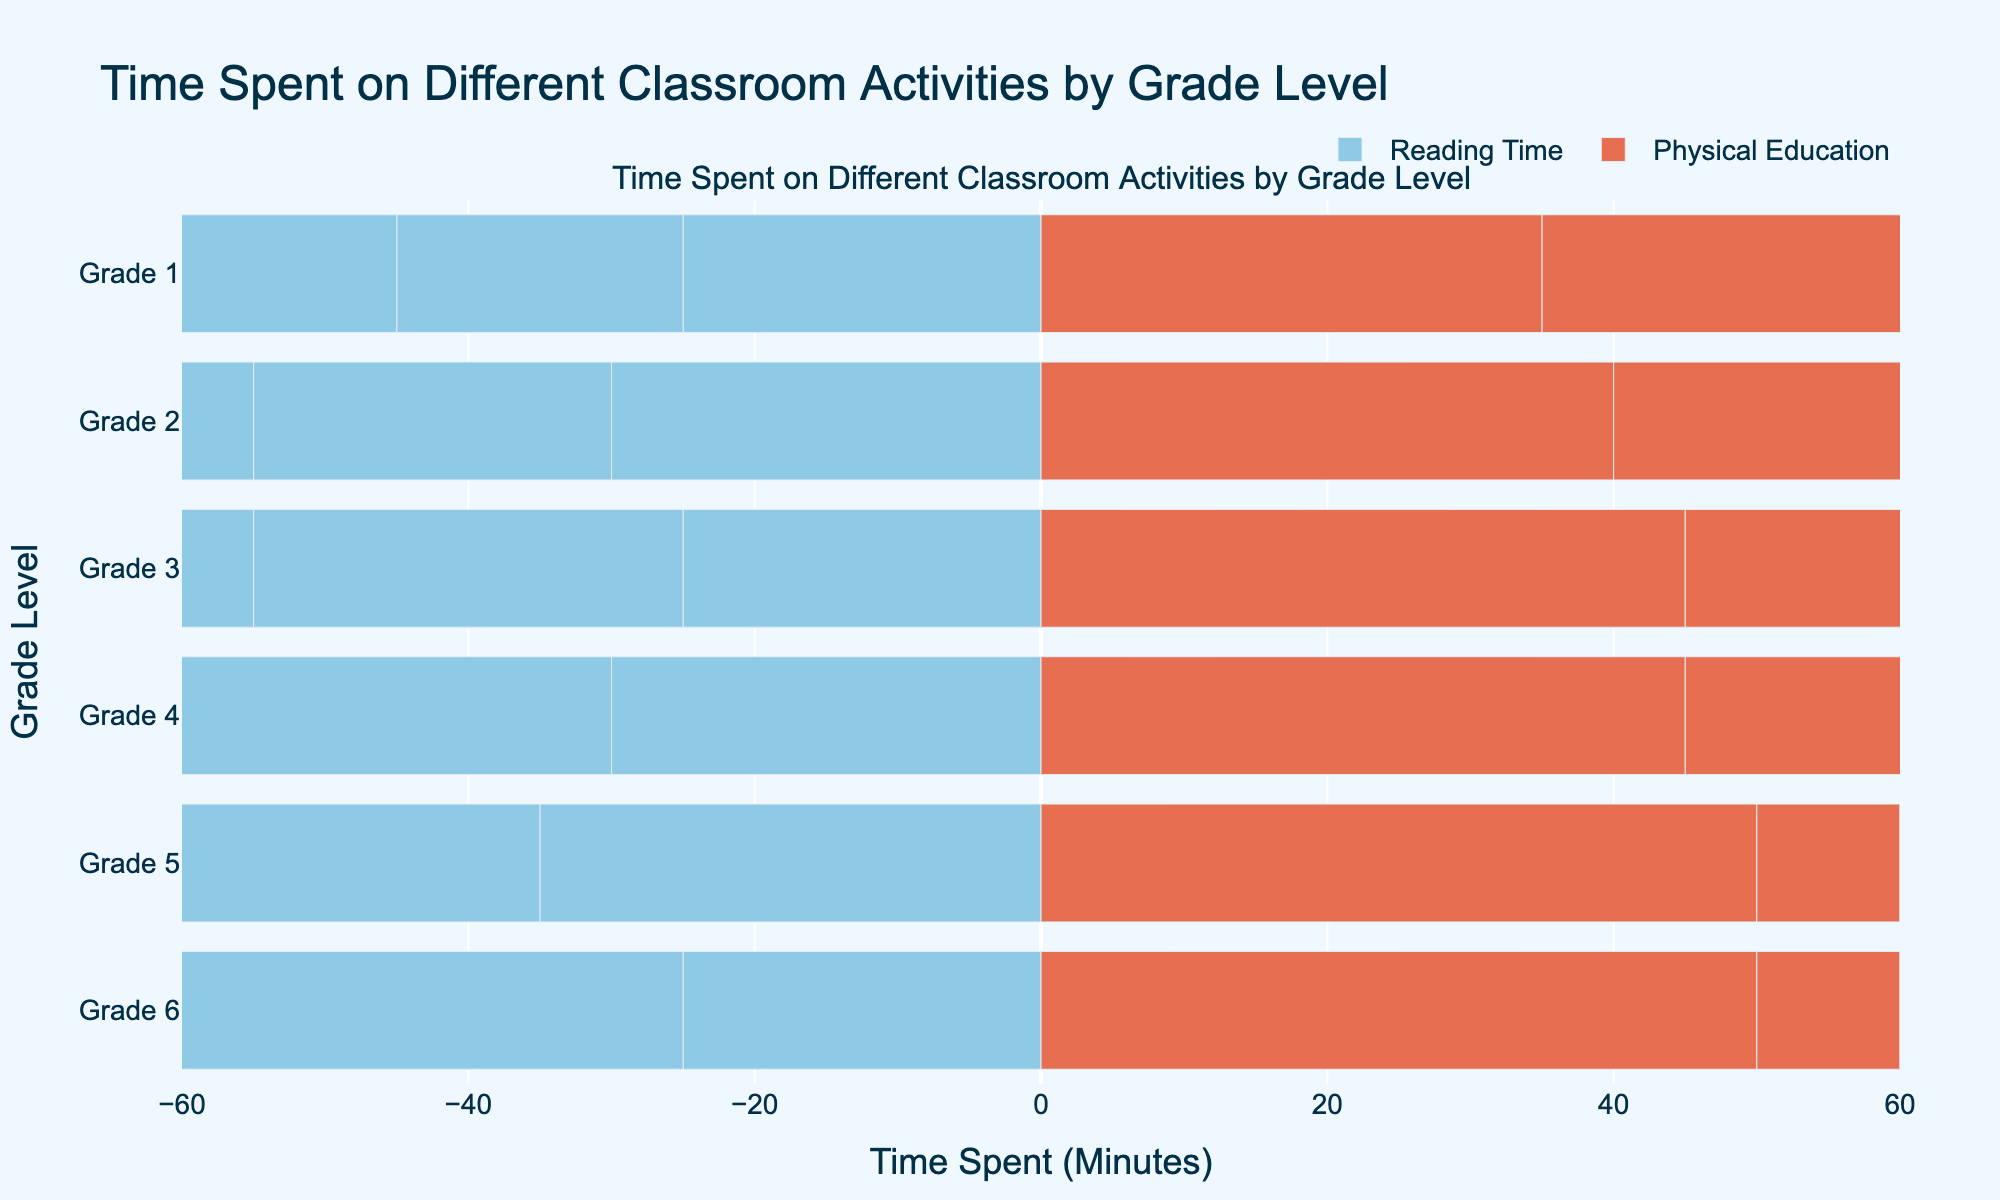What's the total time spent on Reading Time and Math Lessons for Grade 3? For Grade 3: Reading Time is 40 minutes and Math Lessons is 50 minutes. Adding them: 40 + 50 = 90 minutes
Answer: 90 minutes Which grade has the highest total time spent on Physical Education? Check the time values for Physical Education across all grades: Grade 1=35, Grade 2=40, Grade 3=45, Grade 4=45, Grade 5=50, Grade 6=50. The highest value is for Grades 5 and 6.
Answer: Grades 5 and 6 What's the average time spent on Art and Craft across all grades? Time spent on Art and Craft: Grade 1=25, Grade 2=30, Grade 3=25, Grade 4=30, Grade 5=35, Grade 6=25. Calculate the sum: 25 + 30 + 25 + 30 + 35 + 25 = 170. Number of grades is 6. Average: 170 / 6 ≈ 28.33
Answer: ≈ 28.33 minutes Which grade has the smallest time allotted for Snack Break? Check Snack Break times: Grade 1=15, Grade 2=15, Grade 3=10, Grade 4=10, Grade 5=10, Grade 6=10. The smallest value is for Grades 3, 4, 5, and 6.
Answer: Grades 3, 4, 5, and 6 Compare the time spent on Science Experiments between Grade 2 and Grade 4. Which one is higher and by how much? Science Experiments for Grade 2 is 25 minutes and Grade 4 is 35 minutes. Difference: 35 - 25 = 10 minutes.
Answer: Grade 4 by 10 minutes How many classroom activities take more than 30 minutes for Grade 5? For Grade 5, the activities and times are: Reading Time=50, Math Lessons=60, Science Experiments=40, Art and Craft=35, Physical Education=50, Recess=10, Snack Break=10, Social Studies=40, Music=20. Activities > 30 minutes: Reading Time, Math Lessons, Science Experiments, Art and Craft, Physical Education, Social Studies. Total=6 activities.
Answer: 6 activities What is the time difference between Math Lessons and Recess for Grade 6? Grade 6: Math Lessons=60 minutes, Recess=10 minutes. Difference: 60 - 10 = 50 minutes.
Answer: 50 minutes Which activity has the most uniform time distribution across all grades? Check the times of each activity; observe that Music has fairly consistent times: Grade 1=20, Grade 2=20, Grade 3=20, Grade 4=15, Grade 5=20, Grade 6=15. It's the most uniform in terms of minimal variation.
Answer: Music Which activity shows an increasing trend in time spent from Grade 1 to Grade 6? Check if the time values consistently increase for the activities: Reading Time (30, 35, 40, 45, 50, 50) shows an increasing trend.
Answer: Reading Time 